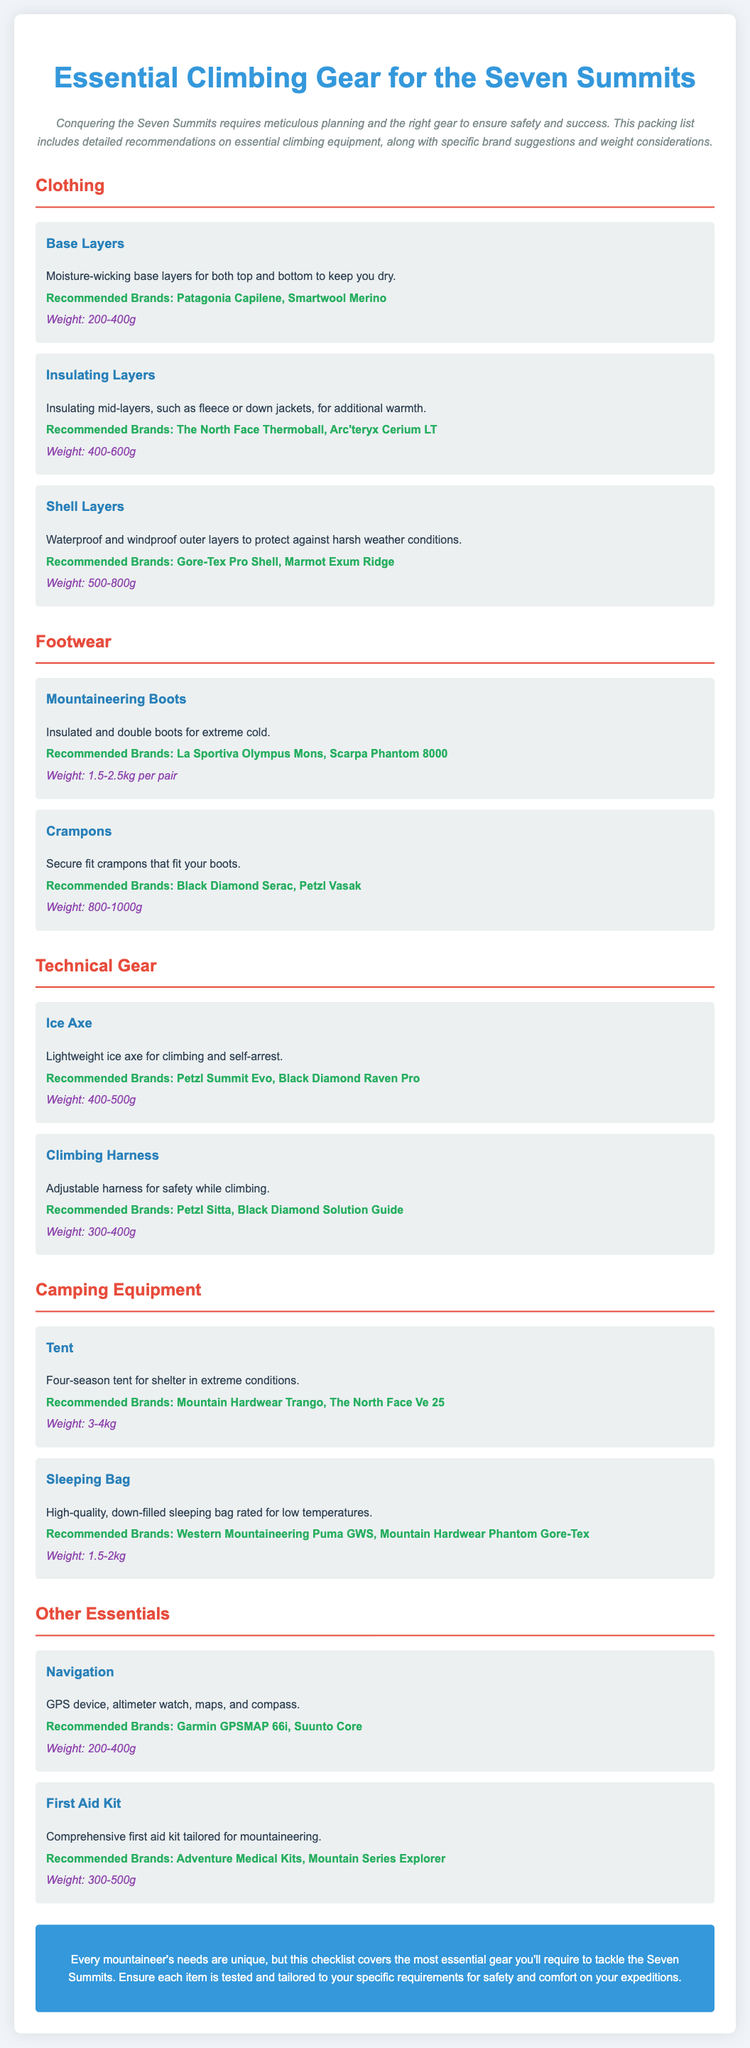What is the recommended brand for base layers? The recommended brands for base layers are mentioned in the clothing section of the document, specifically noting Patagonia Capilene and Smartwool Merino.
Answer: Patagonia Capilene, Smartwool Merino What is the weight range for insulated layers? The weight for insulating layers is specified in the document as part of the clothing category, indicating a range of 400-600g.
Answer: 400-600g What type of tent is recommended? The document describes the tent category, stating that a four-season tent is recommended for shelter in extreme conditions.
Answer: Four-season tent How much do mountaineering boots weigh? Mountaineering boots weight is detailed in the footwear section, specifically noted to be between 1.5-2.5kg per pair.
Answer: 1.5-2.5kg What is the function of the ice axe? The ice axe is described in the technical gear section as being needed for climbing and self-arrest.
Answer: Climbing and self-arrest Which brand is recommended for crampons? The document provides two recommended brands for crampons within the footwear category, listed as Black Diamond Serac and Petzl Vasak.
Answer: Black Diamond Serac, Petzl Vasak What is the weight range of a high-quality sleeping bag? The document specifies the weight range for a high-quality sleeping bag, indicating it should be between 1.5-2kg.
Answer: 1.5-2kg What are essential navigation items mentioned? The navigation requirements are specified in the other essentials section, requiring GPS device, altimeter watch, maps, and compass.
Answer: GPS device, altimeter watch, maps, compass What is the weight of the comprehensive first aid kit? The document mentions the weight of the first aid kit tailored for mountaineering as between 300-500g.
Answer: 300-500g 